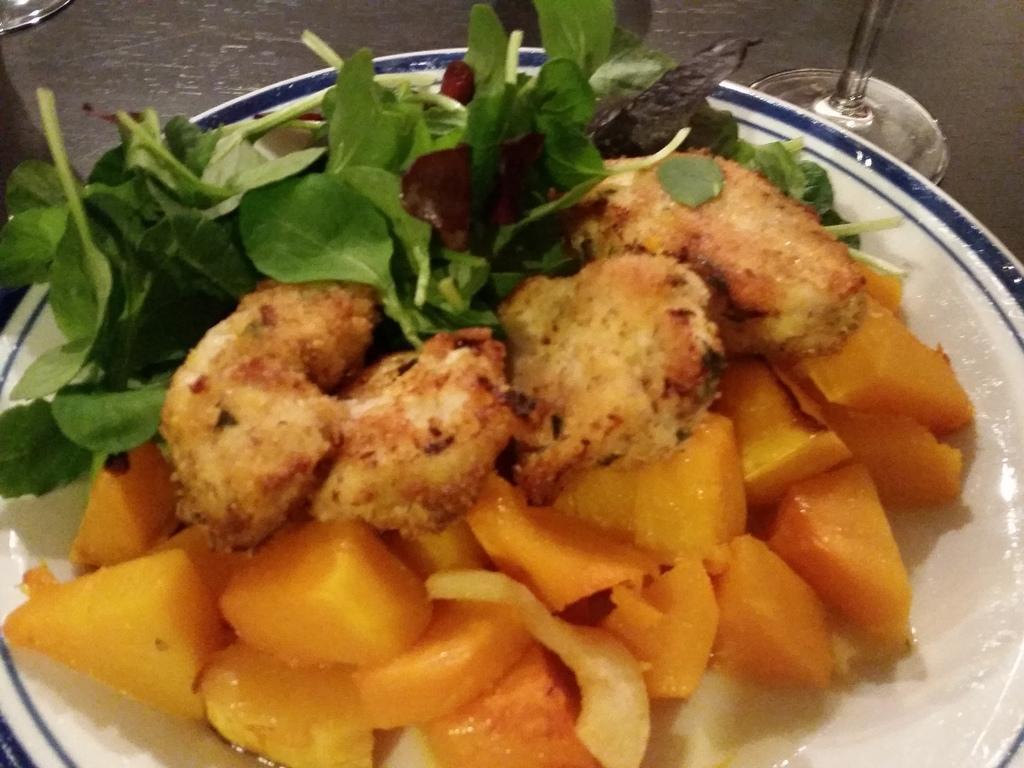How would you summarize this image in a sentence or two? In this image, we can see a plate with some food. On the right side of the image, we can also see a glass. On the left side, we can also see one edge of a glass. In the background, we can see brown color. 